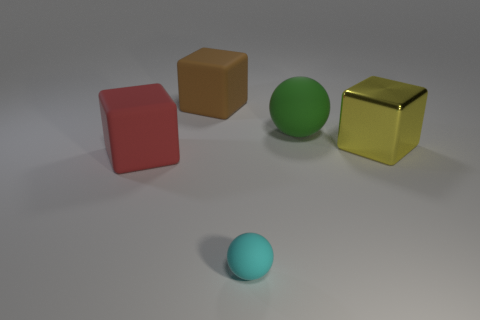Add 1 big green blocks. How many objects exist? 6 Subtract all cubes. How many objects are left? 2 Subtract all green balls. Subtract all yellow rubber objects. How many objects are left? 4 Add 2 large yellow cubes. How many large yellow cubes are left? 3 Add 2 rubber cubes. How many rubber cubes exist? 4 Subtract 0 cyan cubes. How many objects are left? 5 